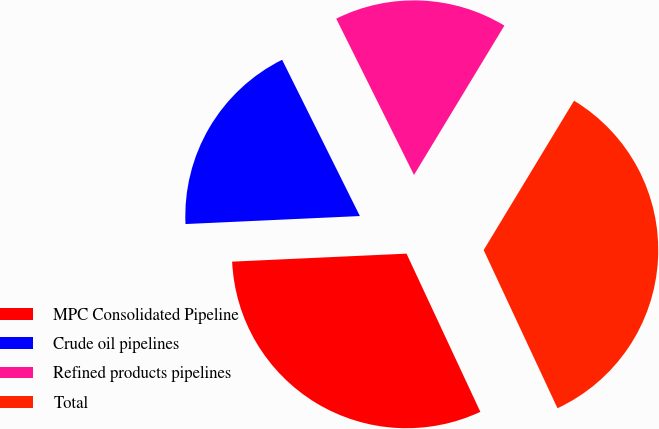<chart> <loc_0><loc_0><loc_500><loc_500><pie_chart><fcel>MPC Consolidated Pipeline<fcel>Crude oil pipelines<fcel>Refined products pipelines<fcel>Total<nl><fcel>31.22%<fcel>18.38%<fcel>16.01%<fcel>34.39%<nl></chart> 